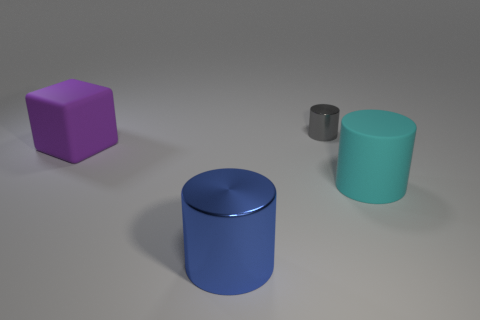There is a matte object to the right of the rubber block; does it have the same size as the matte thing that is on the left side of the small gray object?
Your answer should be compact. Yes. What number of cubes are either big purple things or tiny yellow metal objects?
Ensure brevity in your answer.  1. Are any red metallic cylinders visible?
Ensure brevity in your answer.  No. Is there any other thing that is the same shape as the purple rubber object?
Ensure brevity in your answer.  No. What number of things are either cylinders that are in front of the tiny cylinder or large brown cubes?
Provide a succinct answer. 2. How many shiny objects are to the left of the metal object that is on the right side of the cylinder that is in front of the large rubber cylinder?
Ensure brevity in your answer.  1. Are there any other things that are the same size as the gray shiny cylinder?
Your answer should be compact. No. There is a large rubber object that is in front of the rubber thing to the left of the metallic object in front of the big cube; what shape is it?
Provide a succinct answer. Cylinder. How many other things are there of the same color as the tiny metallic thing?
Provide a short and direct response. 0. What is the shape of the big matte object that is in front of the big thing that is left of the large metal thing?
Make the answer very short. Cylinder. 